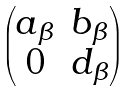<formula> <loc_0><loc_0><loc_500><loc_500>\begin{pmatrix} a _ { \beta } & b _ { \beta } \\ 0 & d _ { \beta } \end{pmatrix}</formula> 